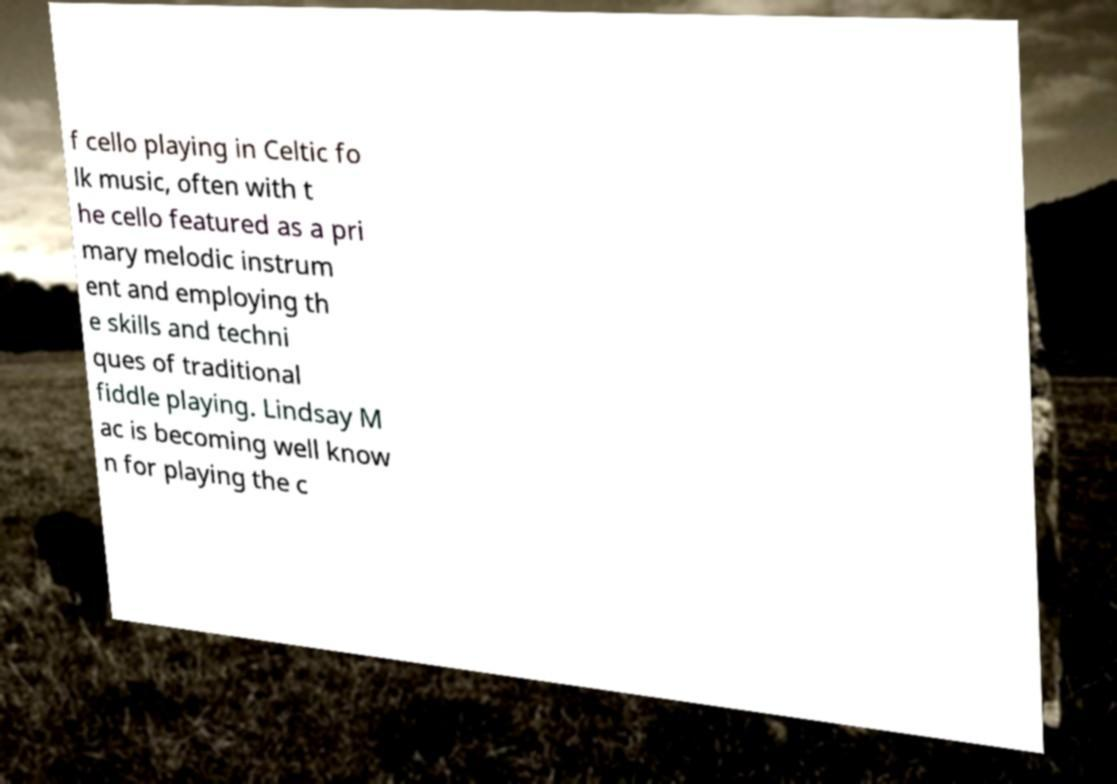Can you read and provide the text displayed in the image?This photo seems to have some interesting text. Can you extract and type it out for me? f cello playing in Celtic fo lk music, often with t he cello featured as a pri mary melodic instrum ent and employing th e skills and techni ques of traditional fiddle playing. Lindsay M ac is becoming well know n for playing the c 